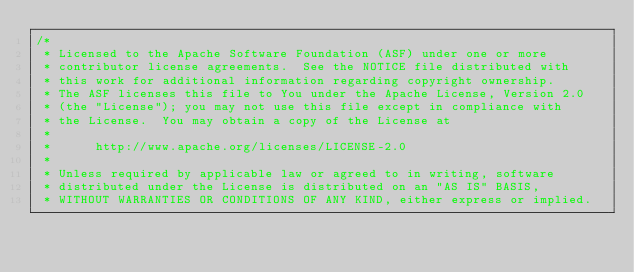<code> <loc_0><loc_0><loc_500><loc_500><_Java_>/*
 * Licensed to the Apache Software Foundation (ASF) under one or more
 * contributor license agreements.  See the NOTICE file distributed with
 * this work for additional information regarding copyright ownership.
 * The ASF licenses this file to You under the Apache License, Version 2.0
 * (the "License"); you may not use this file except in compliance with
 * the License.  You may obtain a copy of the License at
 *
 *      http://www.apache.org/licenses/LICENSE-2.0
 *
 * Unless required by applicable law or agreed to in writing, software
 * distributed under the License is distributed on an "AS IS" BASIS,
 * WITHOUT WARRANTIES OR CONDITIONS OF ANY KIND, either express or implied.</code> 